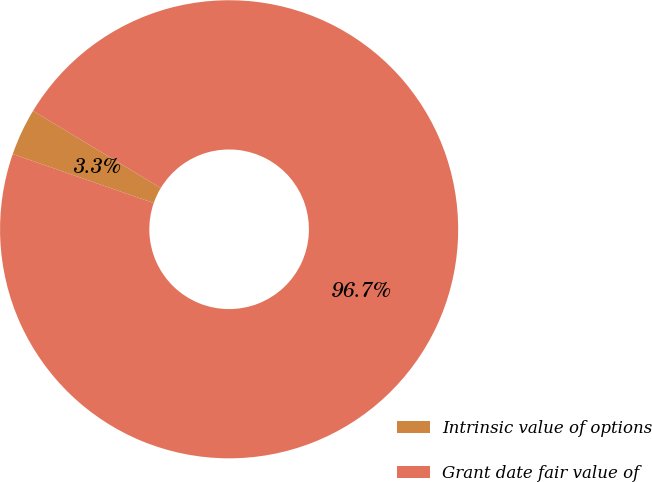Convert chart. <chart><loc_0><loc_0><loc_500><loc_500><pie_chart><fcel>Intrinsic value of options<fcel>Grant date fair value of<nl><fcel>3.32%<fcel>96.68%<nl></chart> 